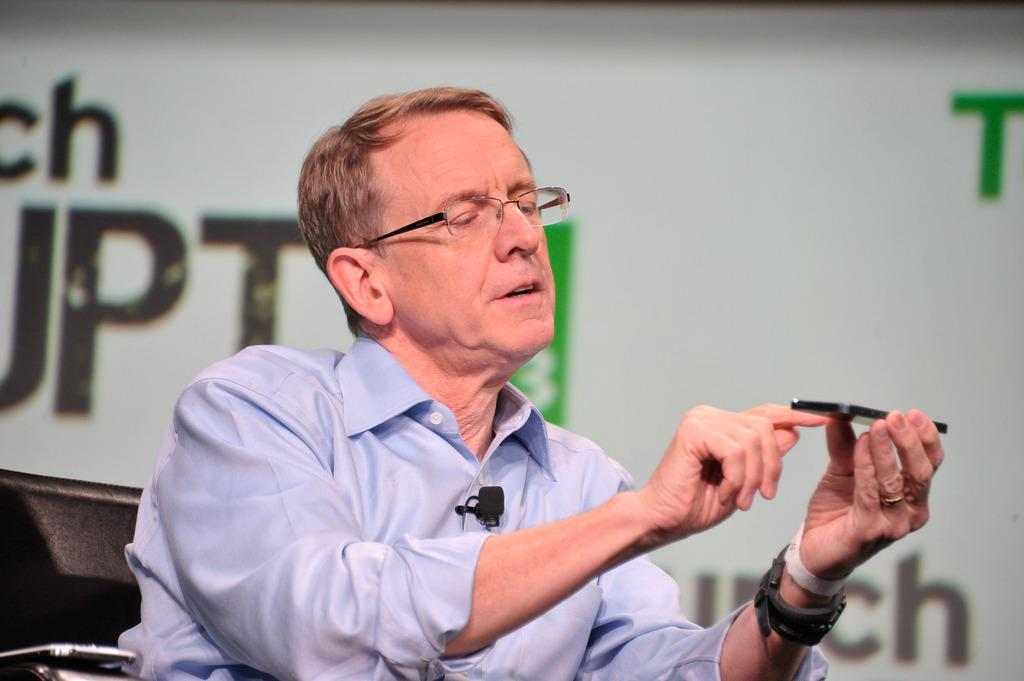What can be seen in the image? There is a person in the image. Can you describe the person's appearance? The person is wearing spectacles. What is the person holding in the image? The person is holding an object. What is visible in the background of the image? There is a banner in the background of the image. What type of book can be seen on the person's head in the image? There is no book present on the person's head in the image. 